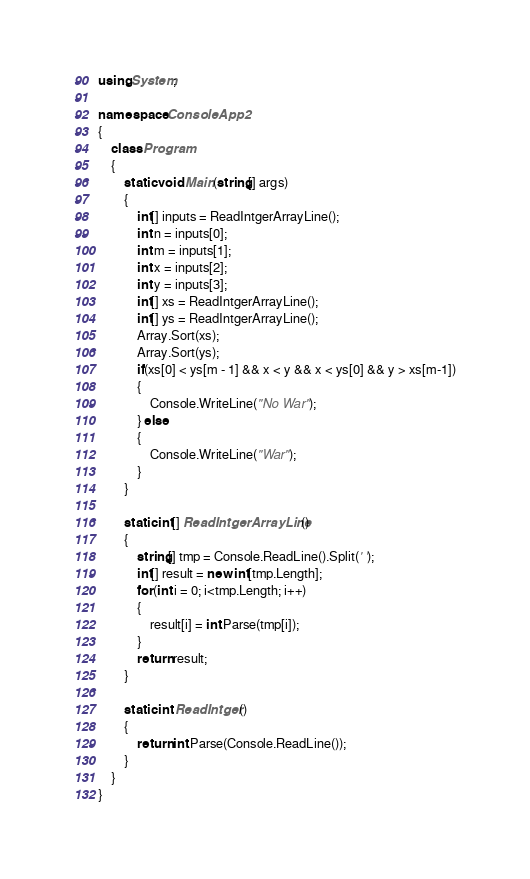<code> <loc_0><loc_0><loc_500><loc_500><_C#_>using System;

namespace ConsoleApp2
{
    class Program
    {
        static void Main(string[] args)
        {
            int[] inputs = ReadIntgerArrayLine();
            int n = inputs[0];
            int m = inputs[1];
            int x = inputs[2];
            int y = inputs[3];
            int[] xs = ReadIntgerArrayLine();
            int[] ys = ReadIntgerArrayLine();
            Array.Sort(xs);
            Array.Sort(ys);
            if(xs[0] < ys[m - 1] && x < y && x < ys[0] && y > xs[m-1])
            {
                Console.WriteLine("No War");
            } else
            {
                Console.WriteLine("War");
            }
        }

        static int[] ReadIntgerArrayLine()
        {
            string[] tmp = Console.ReadLine().Split(' ');
            int[] result = new int[tmp.Length];
            for(int i = 0; i<tmp.Length; i++)
            {
                result[i] = int.Parse(tmp[i]);
            }
            return result;
        }

        static int ReadIntger()
        {
            return int.Parse(Console.ReadLine());
        }
    }
}
</code> 